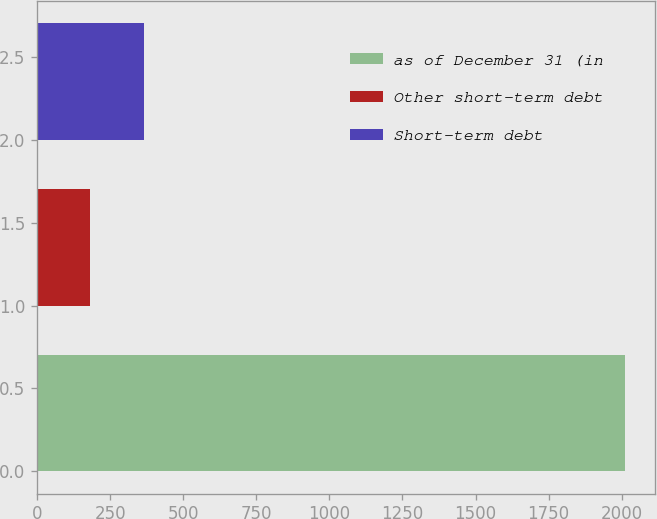Convert chart. <chart><loc_0><loc_0><loc_500><loc_500><bar_chart><fcel>as of December 31 (in<fcel>Other short-term debt<fcel>Short-term debt<nl><fcel>2013<fcel>181<fcel>364.2<nl></chart> 